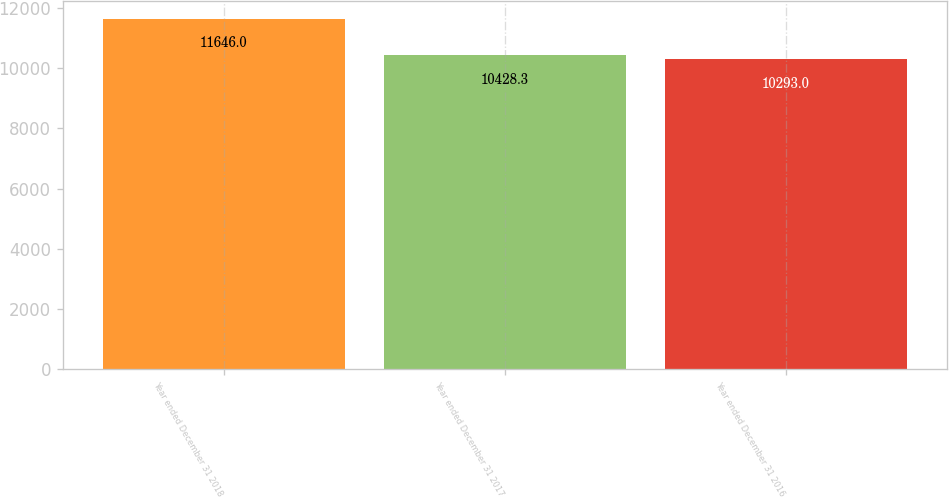Convert chart to OTSL. <chart><loc_0><loc_0><loc_500><loc_500><bar_chart><fcel>Year ended December 31 2018<fcel>Year ended December 31 2017<fcel>Year ended December 31 2016<nl><fcel>11646<fcel>10428.3<fcel>10293<nl></chart> 